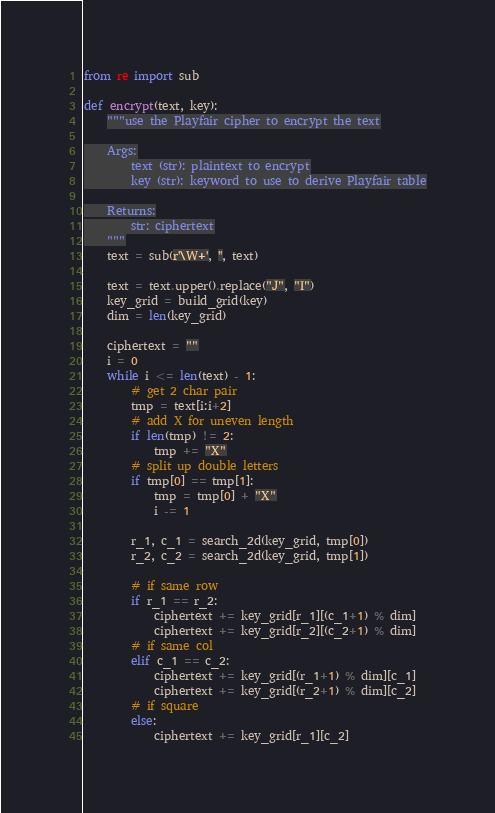Convert code to text. <code><loc_0><loc_0><loc_500><loc_500><_Python_>from re import sub

def encrypt(text, key):
    """use the Playfair cipher to encrypt the text

    Args:
        text (str): plaintext to encrypt
        key (str): keyword to use to derive Playfair table

    Returns:
        str: ciphertext
    """
    text = sub(r'\W+', '', text)

    text = text.upper().replace("J", "I")
    key_grid = build_grid(key)
    dim = len(key_grid)

    ciphertext = ""
    i = 0
    while i <= len(text) - 1:
        # get 2 char pair
        tmp = text[i:i+2]
        # add X for uneven length
        if len(tmp) != 2:
            tmp += "X"
        # split up double letters
        if tmp[0] == tmp[1]:
            tmp = tmp[0] + "X"
            i -= 1

        r_1, c_1 = search_2d(key_grid, tmp[0])
        r_2, c_2 = search_2d(key_grid, tmp[1])

        # if same row
        if r_1 == r_2:
            ciphertext += key_grid[r_1][(c_1+1) % dim]
            ciphertext += key_grid[r_2][(c_2+1) % dim]
        # if same col
        elif c_1 == c_2:
            ciphertext += key_grid[(r_1+1) % dim][c_1]
            ciphertext += key_grid[(r_2+1) % dim][c_2]
        # if square
        else:
            ciphertext += key_grid[r_1][c_2]</code> 